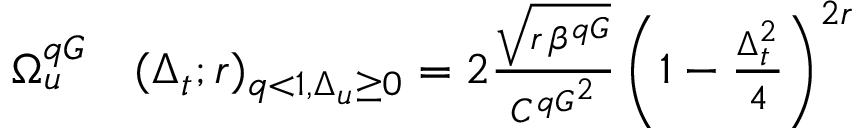Convert formula to latex. <formula><loc_0><loc_0><loc_500><loc_500>\begin{array} { r l } { \Omega _ { u } ^ { q G } } & ( \Delta _ { t } ; r ) _ { q < 1 , \Delta _ { u } \geq 0 } = 2 \frac { \sqrt { r \, \beta ^ { q G } } } { { C ^ { q G } } ^ { 2 } } \left ( 1 - \frac { \Delta _ { t } ^ { 2 } } { 4 } \right ) ^ { 2 r } } \end{array}</formula> 